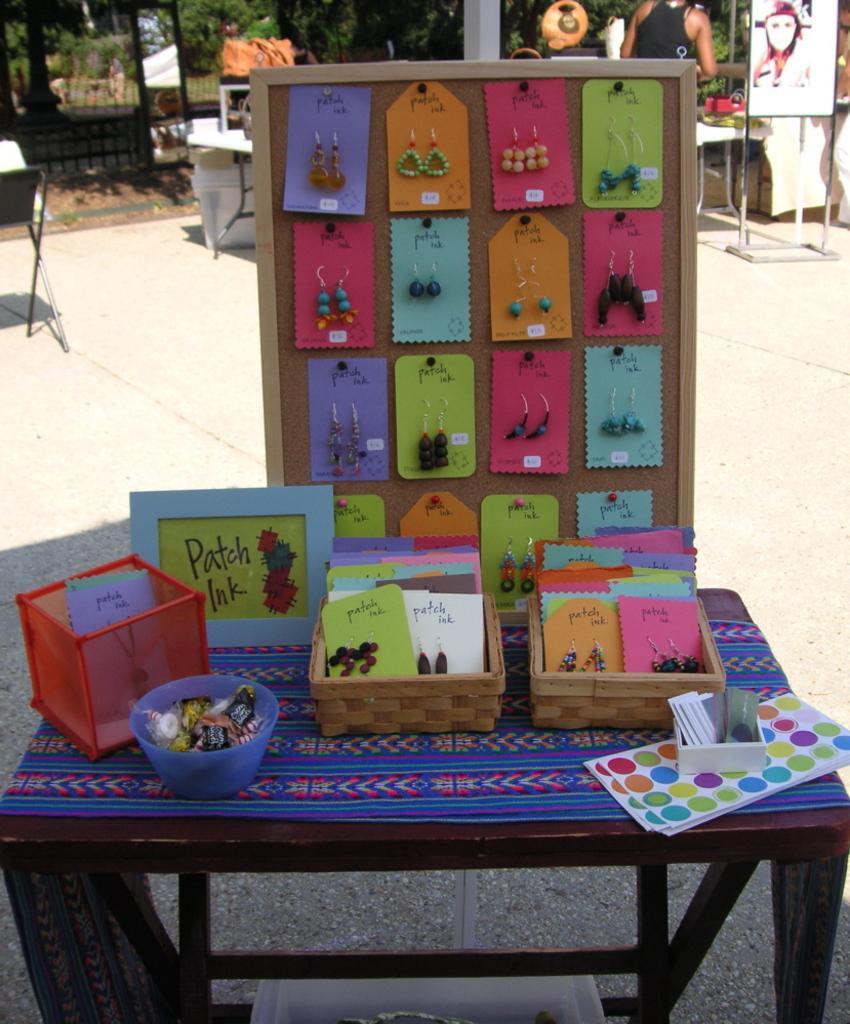Please provide a concise description of this image. In this image I see a table, on which there are few boxes and there are lot of accessories over here. In the background I see few stalls, a person and the trees. 